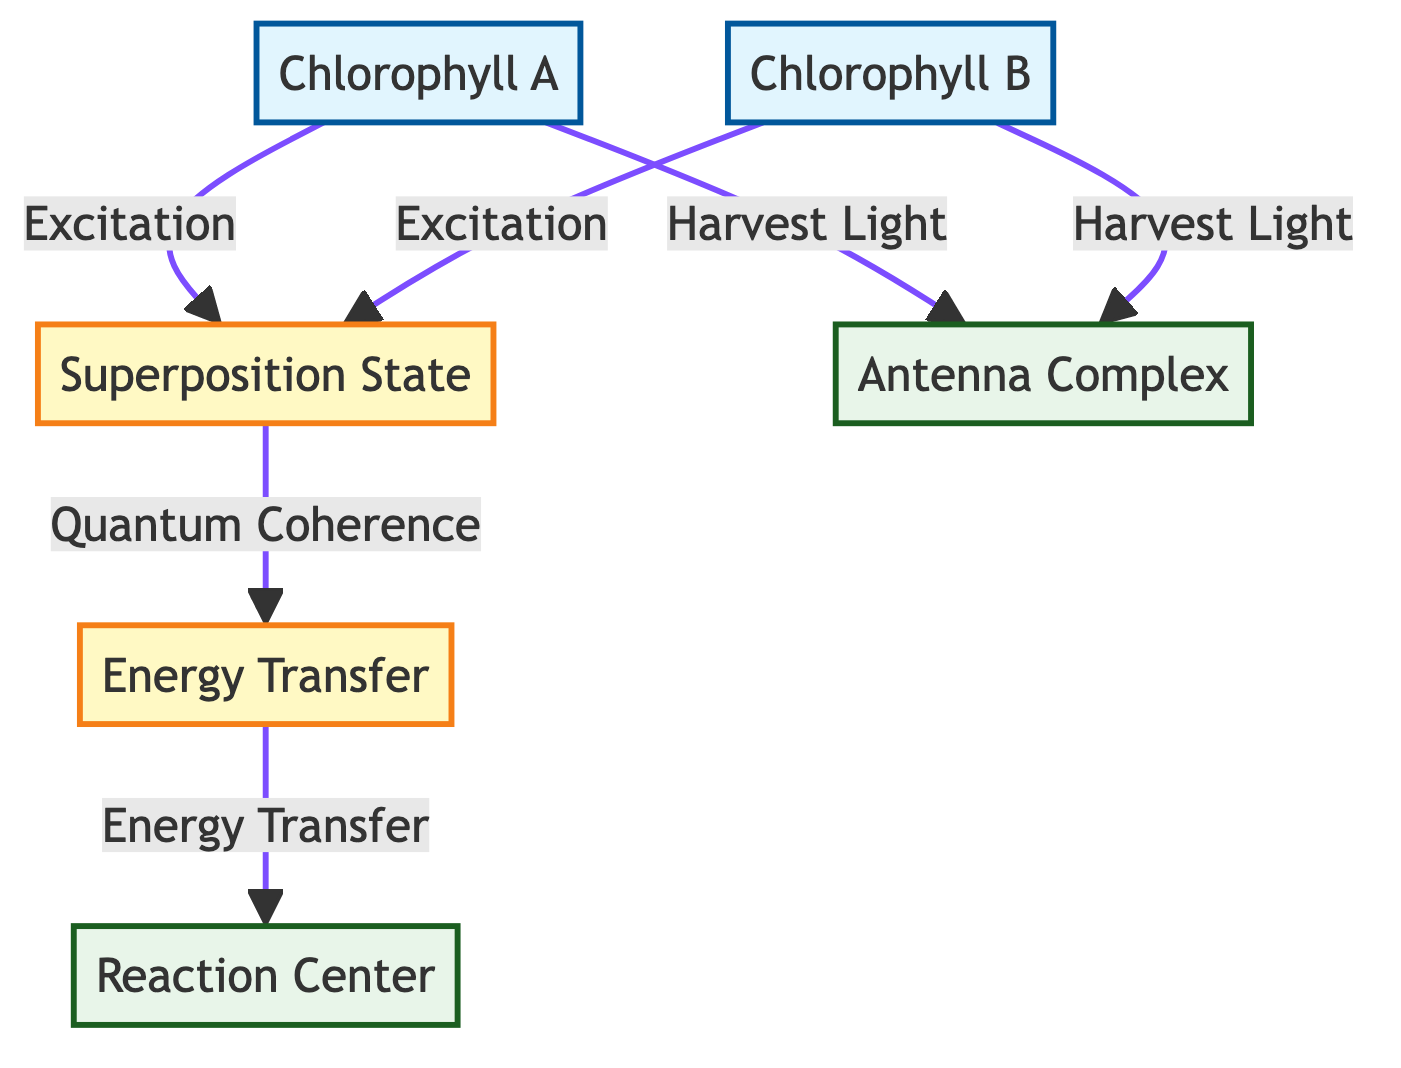What are the two types of chlorophyll molecules depicted? The diagram illustrates "Chlorophyll A" and "Chlorophyll B" as two distinct nodes connected to their corresponding states.
Answer: Chlorophyll A and Chlorophyll B How many types of states are shown in the diagram? The diagram shows two types of states: "Superposition State" and "Energy Transfer." To count, observe the state nodes in the diagram.
Answer: Two Which molecule initiates the process of harvesting light? The diagram connects "Chlorophyll A" and "Chlorophyll B" directly to the "Antenna Complex," indicating that they both participate in harvesting light before leading to other processes.
Answer: Chlorophyll A What is the next step after the superposition state? The flow from "Superposition State" leads to "Energy Transfer," indicating that the next step occurs there after achieving a superposition of states.
Answer: Energy Transfer What type of complex is the reaction center classified as? In the diagram, "Reaction Center" is designated as a complex node, which can be identified by its distinct class definition and label in the visual structure.
Answer: Complex Which process follows energy transfer in the diagram? The diagram flows from "Energy Transfer" to "Reaction Center," showing that energy transfer directly leads to reactions in the reaction center.
Answer: Reaction Center What indicates the quantum coherence in the transfer pathway? The flow from "Superposition State" to "Energy Transfer" is marked as being influenced by "Quantum Coherence," indicating how coherence plays a role in energy transfer.
Answer: Quantum Coherence What are the primary functions of chlorophyll molecules in the diagram? The diagram shows two functions: "Excitation" linked to chlorophyll molecules and "Harvest Light" connected through arrows to the "Antenna Complex."
Answer: Excitation and Harvest Light How many edges connect chlorophyll molecules to the antenna complex? Both "Chlorophyll A" and "Chlorophyll B" have separate edges leading to the "Antenna Complex," totaling two connections.
Answer: Two 